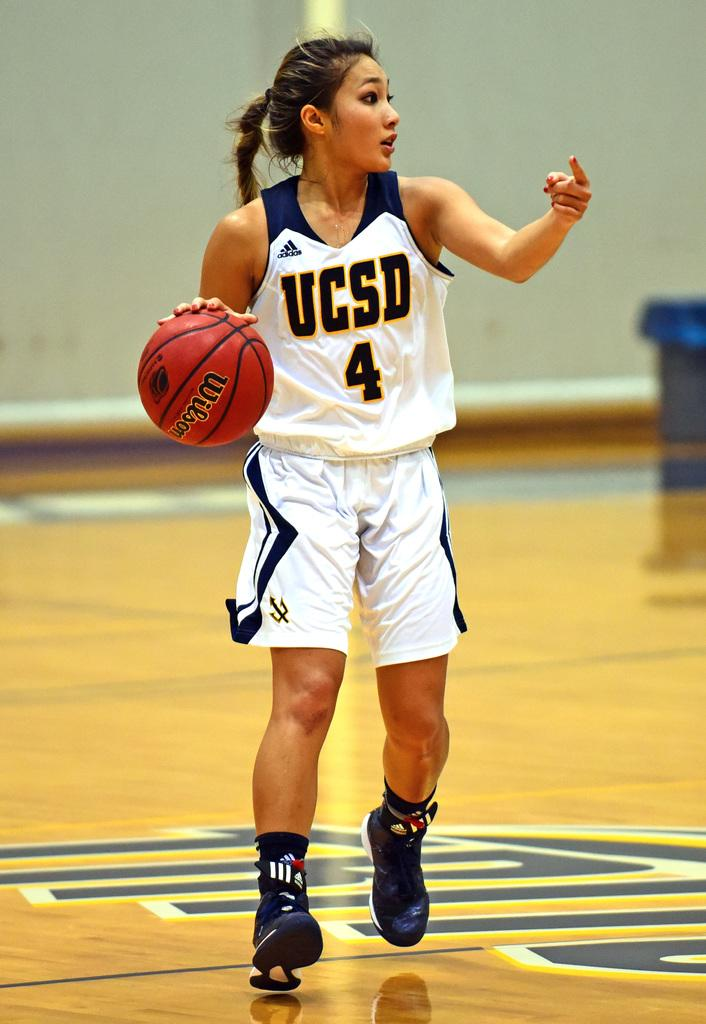<image>
Share a concise interpretation of the image provided. UCSD basketball player number 4 in white and blue is dribbling the ball down the court. 